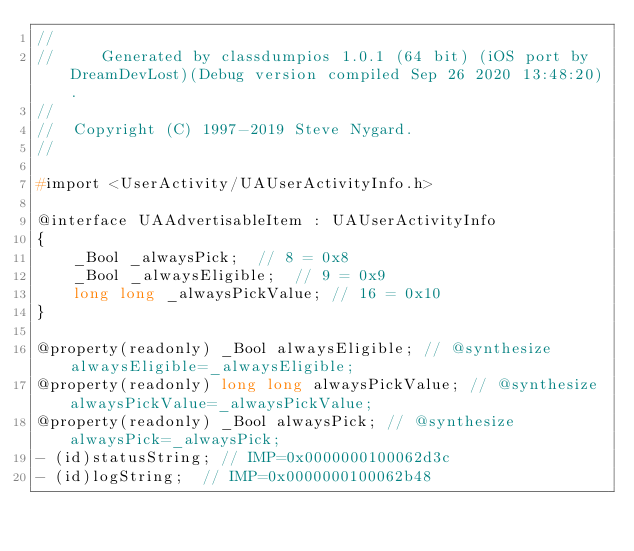Convert code to text. <code><loc_0><loc_0><loc_500><loc_500><_C_>//
//     Generated by classdumpios 1.0.1 (64 bit) (iOS port by DreamDevLost)(Debug version compiled Sep 26 2020 13:48:20).
//
//  Copyright (C) 1997-2019 Steve Nygard.
//

#import <UserActivity/UAUserActivityInfo.h>

@interface UAAdvertisableItem : UAUserActivityInfo
{
    _Bool _alwaysPick;	// 8 = 0x8
    _Bool _alwaysEligible;	// 9 = 0x9
    long long _alwaysPickValue;	// 16 = 0x10
}

@property(readonly) _Bool alwaysEligible; // @synthesize alwaysEligible=_alwaysEligible;
@property(readonly) long long alwaysPickValue; // @synthesize alwaysPickValue=_alwaysPickValue;
@property(readonly) _Bool alwaysPick; // @synthesize alwaysPick=_alwaysPick;
- (id)statusString;	// IMP=0x0000000100062d3c
- (id)logString;	// IMP=0x0000000100062b48</code> 